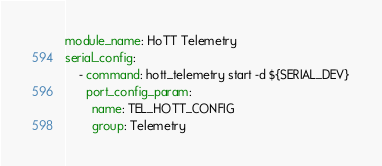<code> <loc_0><loc_0><loc_500><loc_500><_YAML_>module_name: HoTT Telemetry
serial_config:
    - command: hott_telemetry start -d ${SERIAL_DEV}
      port_config_param:
        name: TEL_HOTT_CONFIG
        group: Telemetry

</code> 